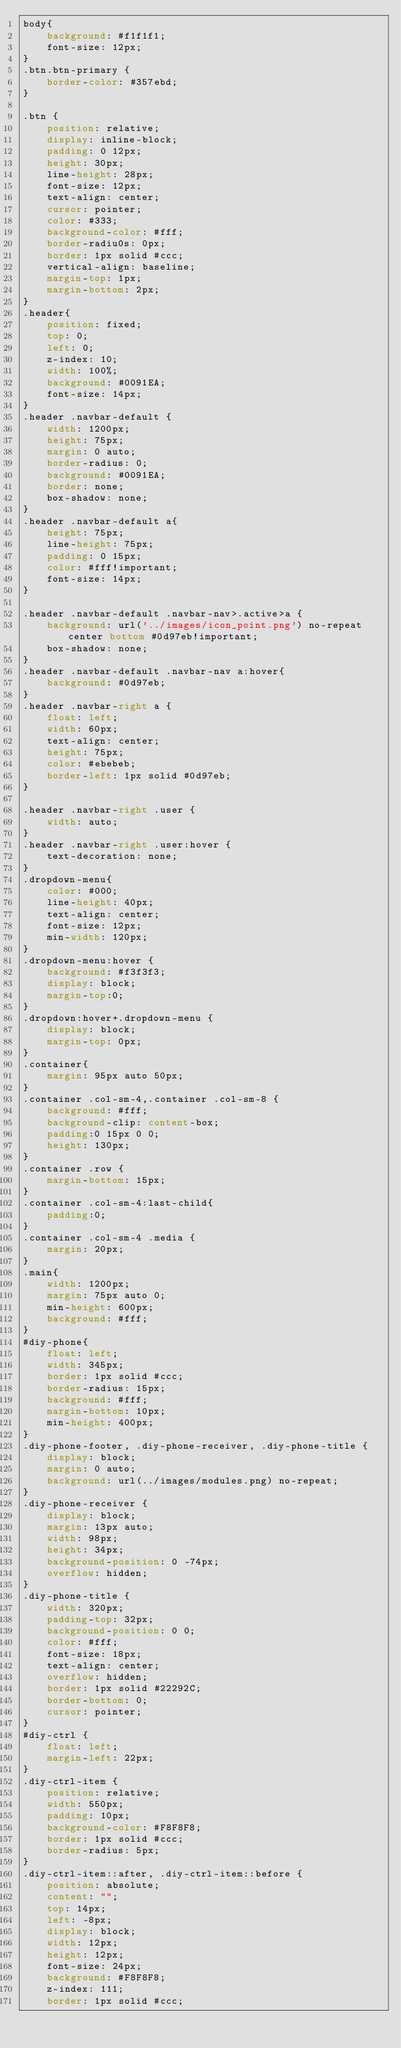Convert code to text. <code><loc_0><loc_0><loc_500><loc_500><_CSS_>body{
    background: #f1f1f1;
    font-size: 12px;
}
.btn.btn-primary {
    border-color: #357ebd;
}

.btn {
    position: relative;
    display: inline-block;
    padding: 0 12px;
    height: 30px;
    line-height: 28px;
    font-size: 12px;
    text-align: center;
    cursor: pointer;
    color: #333;
    background-color: #fff;
    border-radiu0s: 0px;
    border: 1px solid #ccc;
    vertical-align: baseline;
    margin-top: 1px;
    margin-bottom: 2px;
}
.header{
    position: fixed;
    top: 0;
    left: 0;
    z-index: 10;
    width: 100%;
    background: #0091EA;
    font-size: 14px;
}
.header .navbar-default {
    width: 1200px;
    height: 75px;
    margin: 0 auto;
    border-radius: 0;
    background: #0091EA;
    border: none;
    box-shadow: none;
}
.header .navbar-default a{
    height: 75px;
    line-height: 75px;
    padding: 0 15px;
    color: #fff!important;
    font-size: 14px;
}

.header .navbar-default .navbar-nav>.active>a {
    background: url('../images/icon_point.png') no-repeat center bottom #0d97eb!important;
    box-shadow: none;
}
.header .navbar-default .navbar-nav a:hover{
    background: #0d97eb;
}
.header .navbar-right a {
    float: left;
    width: 60px;
    text-align: center;
    height: 75px;
    color: #ebebeb;
    border-left: 1px solid #0d97eb;
}

.header .navbar-right .user {
    width: auto;
}
.header .navbar-right .user:hover {
    text-decoration: none;
}
.dropdown-menu{
    color: #000;
    line-height: 40px;
    text-align: center;
    font-size: 12px;
    min-width: 120px;
}
.dropdown-menu:hover {
    background: #f3f3f3;
    display: block;
    margin-top:0;
}
.dropdown:hover+.dropdown-menu {
    display: block;
    margin-top: 0px;
}
.container{
    margin: 95px auto 50px;
}
.container .col-sm-4,.container .col-sm-8 {
    background: #fff;
    background-clip: content-box;
    padding:0 15px 0 0;
    height: 130px;
}
.container .row {
    margin-bottom: 15px;
}
.container .col-sm-4:last-child{
    padding:0;
}
.container .col-sm-4 .media {
    margin: 20px;
}
.main{
    width: 1200px;
    margin: 75px auto 0;
    min-height: 600px;
    background: #fff;
}
#diy-phone{
    float: left;
    width: 345px;
    border: 1px solid #ccc;
    border-radius: 15px;
    background: #fff;
    margin-bottom: 10px;
    min-height: 400px;
}
.diy-phone-footer, .diy-phone-receiver, .diy-phone-title {
    display: block;
    margin: 0 auto;
    background: url(../images/modules.png) no-repeat;
}
.diy-phone-receiver {
    display: block;
    margin: 13px auto;
    width: 98px;
    height: 34px;
    background-position: 0 -74px;
    overflow: hidden;
}
.diy-phone-title {
    width: 320px;
    padding-top: 32px;
    background-position: 0 0;
    color: #fff;
    font-size: 18px;
    text-align: center;
    overflow: hidden;
    border: 1px solid #22292C;
    border-bottom: 0;
    cursor: pointer;
}
#diy-ctrl {
    float: left;
    margin-left: 22px;
}
.diy-ctrl-item {
    position: relative;
    width: 550px;
    padding: 10px;
    background-color: #F8F8F8;
    border: 1px solid #ccc;
    border-radius: 5px;
}
.diy-ctrl-item::after, .diy-ctrl-item::before {
    position: absolute;
    content: "";
    top: 14px;
    left: -8px;
    display: block;
    width: 12px;
    height: 12px;
    font-size: 24px;
    background: #F8F8F8;
    z-index: 111;
    border: 1px solid #ccc;</code> 